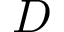<formula> <loc_0><loc_0><loc_500><loc_500>D</formula> 